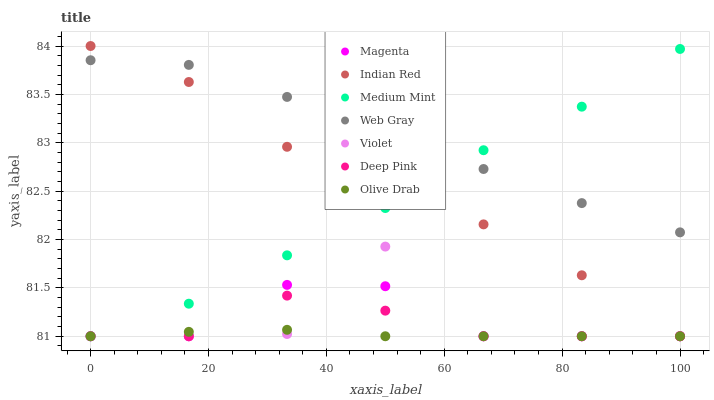Does Olive Drab have the minimum area under the curve?
Answer yes or no. Yes. Does Web Gray have the maximum area under the curve?
Answer yes or no. Yes. Does Deep Pink have the minimum area under the curve?
Answer yes or no. No. Does Deep Pink have the maximum area under the curve?
Answer yes or no. No. Is Olive Drab the smoothest?
Answer yes or no. Yes. Is Violet the roughest?
Answer yes or no. Yes. Is Web Gray the smoothest?
Answer yes or no. No. Is Web Gray the roughest?
Answer yes or no. No. Does Medium Mint have the lowest value?
Answer yes or no. Yes. Does Web Gray have the lowest value?
Answer yes or no. No. Does Indian Red have the highest value?
Answer yes or no. Yes. Does Web Gray have the highest value?
Answer yes or no. No. Is Deep Pink less than Web Gray?
Answer yes or no. Yes. Is Web Gray greater than Deep Pink?
Answer yes or no. Yes. Does Web Gray intersect Medium Mint?
Answer yes or no. Yes. Is Web Gray less than Medium Mint?
Answer yes or no. No. Is Web Gray greater than Medium Mint?
Answer yes or no. No. Does Deep Pink intersect Web Gray?
Answer yes or no. No. 